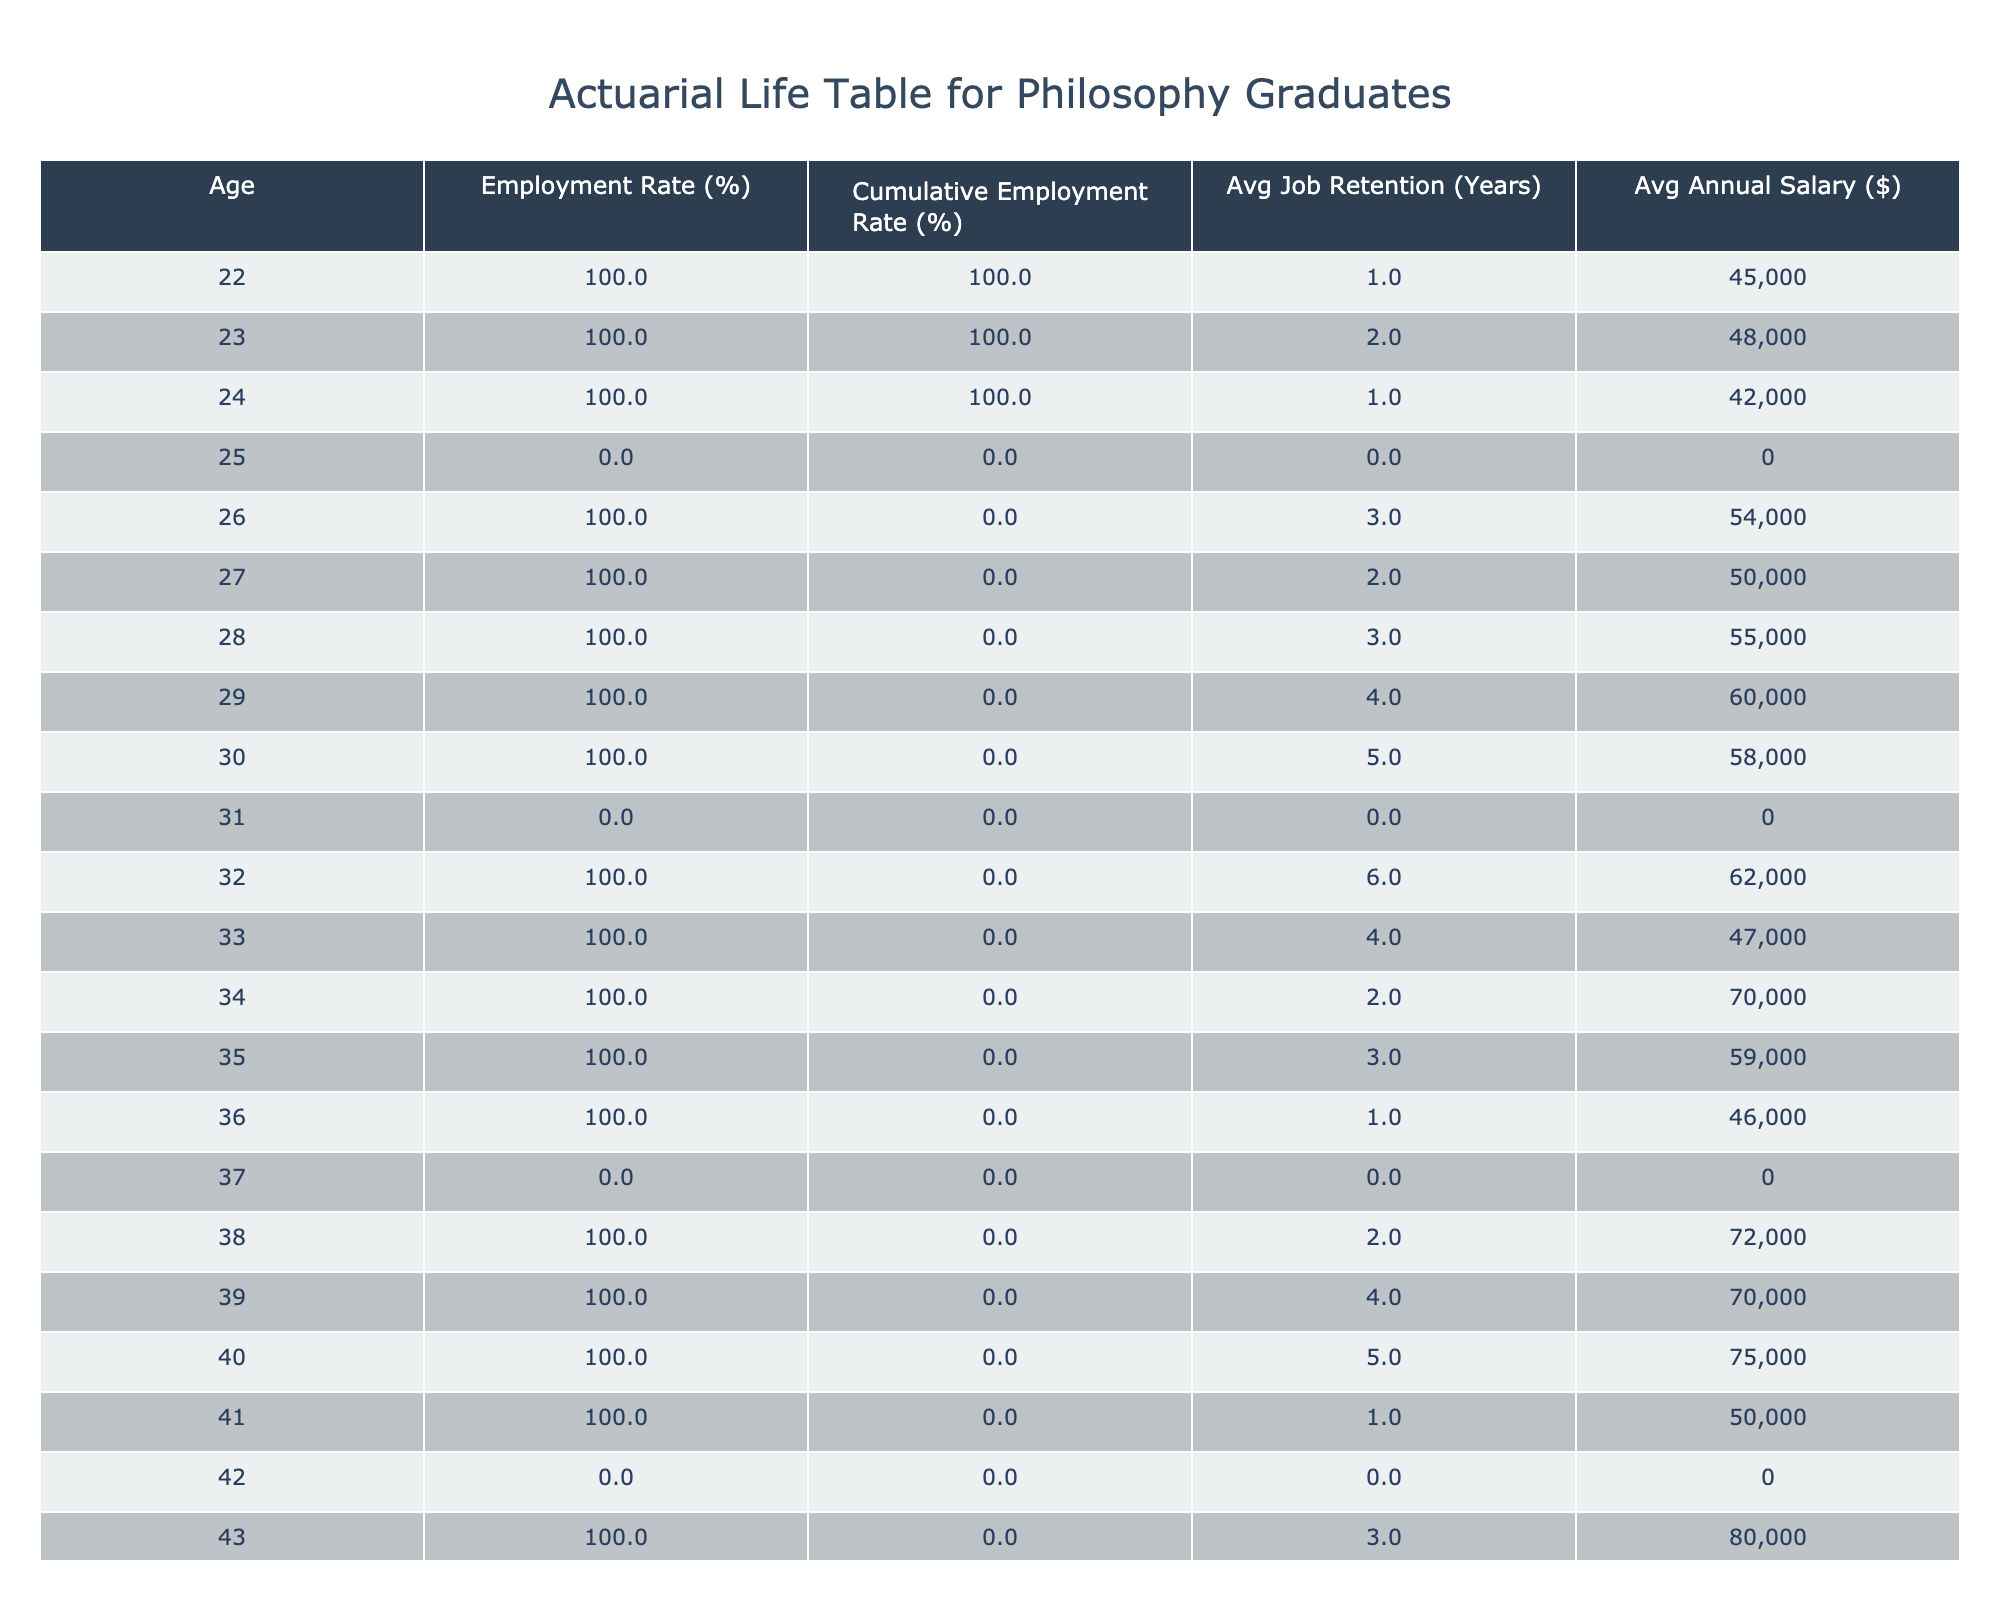What is the employment rate for philosophy graduates at age 30? From the table, the employment rate at age 30 is specifically stated under the Employment Rate (%) column. By looking directly at this age group, I find that the employment rate is 100%.
Answer: 100% What is the average annual salary of philosophy graduates at age 40? The average annual salary can be found directly by checking the Annual Salary column for age 40. The table shows an average salary of 75,000 for this age group.
Answer: 75000 How many years, on average, do philosophy graduates retain a job by age 35? To answer this, I look at the Avg Job Retention (Years) for age 35 in the table. It states that the average job retention is 3 years at this age.
Answer: 3 Is the cumulative employment rate at age 25 higher than at age 24? To answer this, I need to check the Cumulative Employment Rate (%) values at ages 25 and 24. The table shows that for age 25 the rate is 84.6% and at age 24 it is 84.6%. Thus, the two values are equal.
Answer: No What is the difference in average job retention between ages 32 and 38? I will find the Avg Job Retention (Years) for both ages. For age 32, it is 6 years, and for age 38, it is 2 years. To find the difference, I subtract 2 from 6, which equals 4 years of difference in job retention.
Answer: 4 What is the cumulative employment rate at age 44? The cumulative employment rate for age 44 can be extracted directly from the table under the Cumulative Employment Rate (%) column. It shows that the rate at this age is 82.5%.
Answer: 82.5 Do philosophy graduates aged 46 report any employment status? The data for age 46 shows that the employment status is listed as unemployed with no recorded annual salary. This indicates that there is no employment reported at this age.
Answer: Yes What is the highest average annual salary reported for philosophy graduates between ages 22 and 50? I need to check the Annual Salary column for each age between 22 and 50, identifying the highest figure. Upon review, age 48 shows the highest average salary of 100,000.
Answer: 100000 